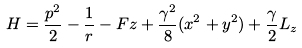<formula> <loc_0><loc_0><loc_500><loc_500>H = \frac { { p } ^ { 2 } } { 2 } - \frac { 1 } { r } - F z + \frac { \gamma ^ { 2 } } { 8 } ( x ^ { 2 } + y ^ { 2 } ) + \frac { \gamma } { 2 } L _ { z }</formula> 